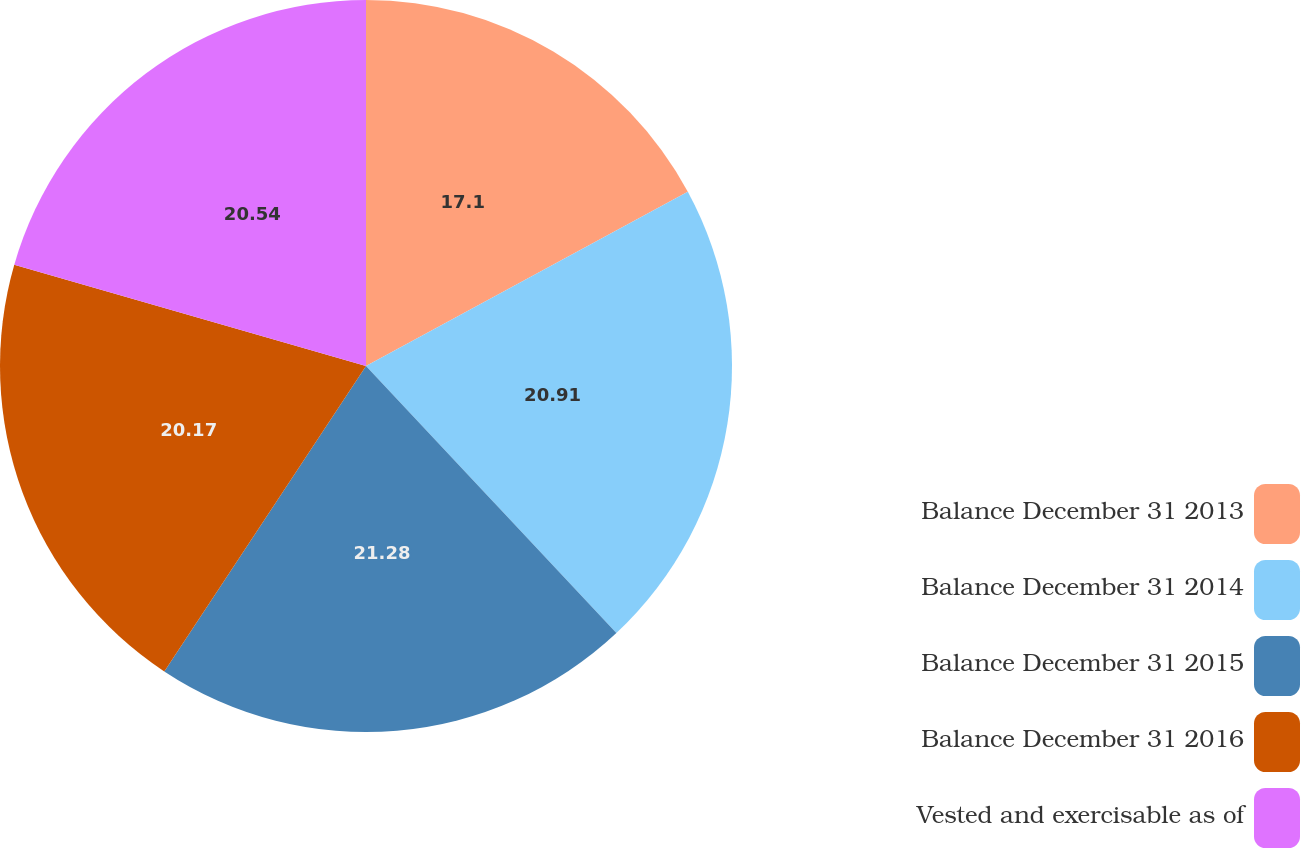Convert chart. <chart><loc_0><loc_0><loc_500><loc_500><pie_chart><fcel>Balance December 31 2013<fcel>Balance December 31 2014<fcel>Balance December 31 2015<fcel>Balance December 31 2016<fcel>Vested and exercisable as of<nl><fcel>17.1%<fcel>20.91%<fcel>21.28%<fcel>20.17%<fcel>20.54%<nl></chart> 